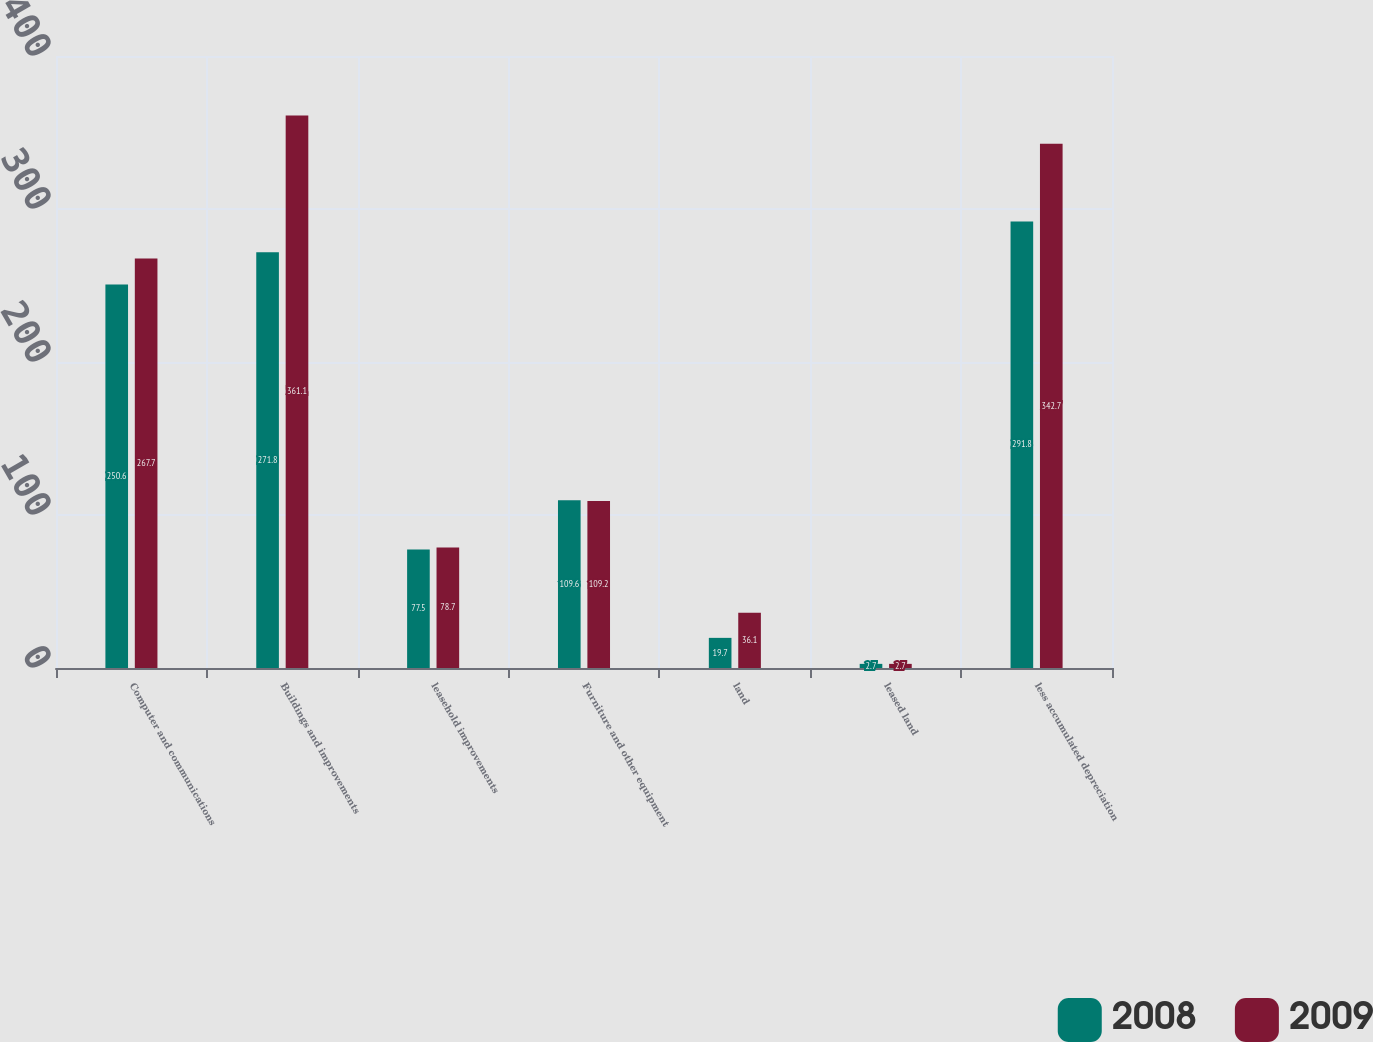Convert chart to OTSL. <chart><loc_0><loc_0><loc_500><loc_500><stacked_bar_chart><ecel><fcel>Computer and communications<fcel>Buildings and improvements<fcel>leasehold improvements<fcel>Furniture and other equipment<fcel>land<fcel>leased land<fcel>less accumulated depreciation<nl><fcel>2008<fcel>250.6<fcel>271.8<fcel>77.5<fcel>109.6<fcel>19.7<fcel>2.7<fcel>291.8<nl><fcel>2009<fcel>267.7<fcel>361.1<fcel>78.7<fcel>109.2<fcel>36.1<fcel>2.7<fcel>342.7<nl></chart> 